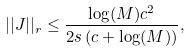<formula> <loc_0><loc_0><loc_500><loc_500>| | J | | _ { r } \leq \frac { \log ( M ) c ^ { 2 } } { 2 s \left ( c + \log ( M ) \right ) } ,</formula> 